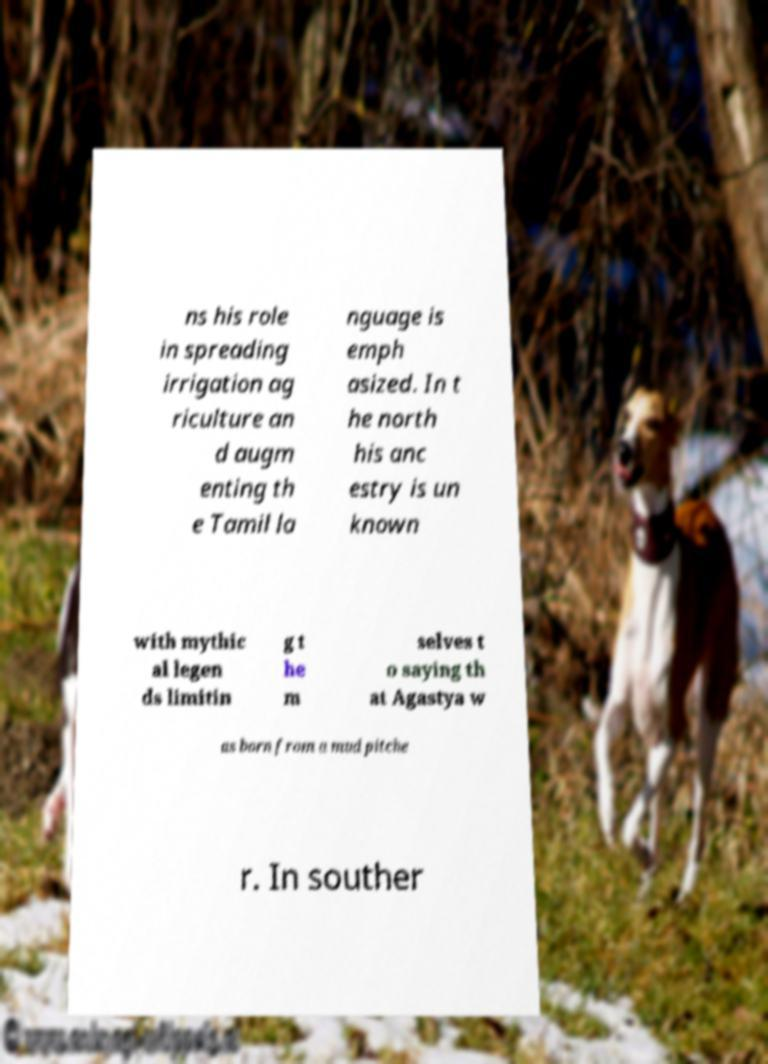For documentation purposes, I need the text within this image transcribed. Could you provide that? ns his role in spreading irrigation ag riculture an d augm enting th e Tamil la nguage is emph asized. In t he north his anc estry is un known with mythic al legen ds limitin g t he m selves t o saying th at Agastya w as born from a mud pitche r. In souther 